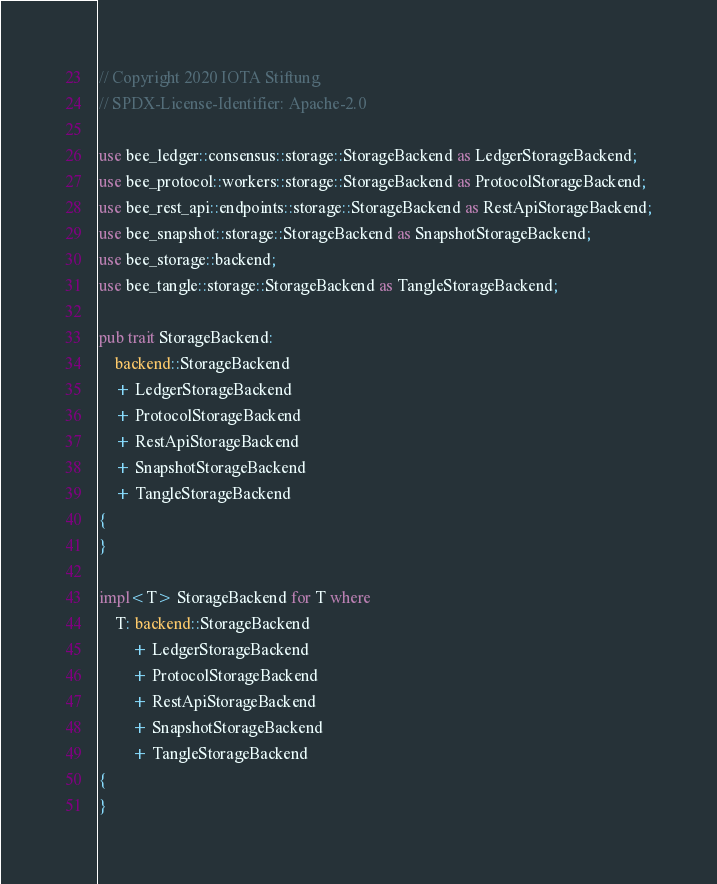<code> <loc_0><loc_0><loc_500><loc_500><_Rust_>// Copyright 2020 IOTA Stiftung
// SPDX-License-Identifier: Apache-2.0

use bee_ledger::consensus::storage::StorageBackend as LedgerStorageBackend;
use bee_protocol::workers::storage::StorageBackend as ProtocolStorageBackend;
use bee_rest_api::endpoints::storage::StorageBackend as RestApiStorageBackend;
use bee_snapshot::storage::StorageBackend as SnapshotStorageBackend;
use bee_storage::backend;
use bee_tangle::storage::StorageBackend as TangleStorageBackend;

pub trait StorageBackend:
    backend::StorageBackend
    + LedgerStorageBackend
    + ProtocolStorageBackend
    + RestApiStorageBackend
    + SnapshotStorageBackend
    + TangleStorageBackend
{
}

impl<T> StorageBackend for T where
    T: backend::StorageBackend
        + LedgerStorageBackend
        + ProtocolStorageBackend
        + RestApiStorageBackend
        + SnapshotStorageBackend
        + TangleStorageBackend
{
}
</code> 